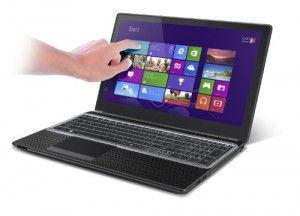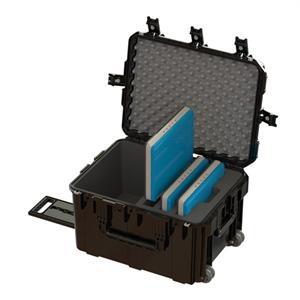The first image is the image on the left, the second image is the image on the right. Examine the images to the left and right. Is the description "There are at least 3 laptops in the image on the left." accurate? Answer yes or no. No. The first image is the image on the left, the second image is the image on the right. Assess this claim about the two images: "In at least one image there is a single laptop with a blue full screen touch menu.". Correct or not? Answer yes or no. Yes. 